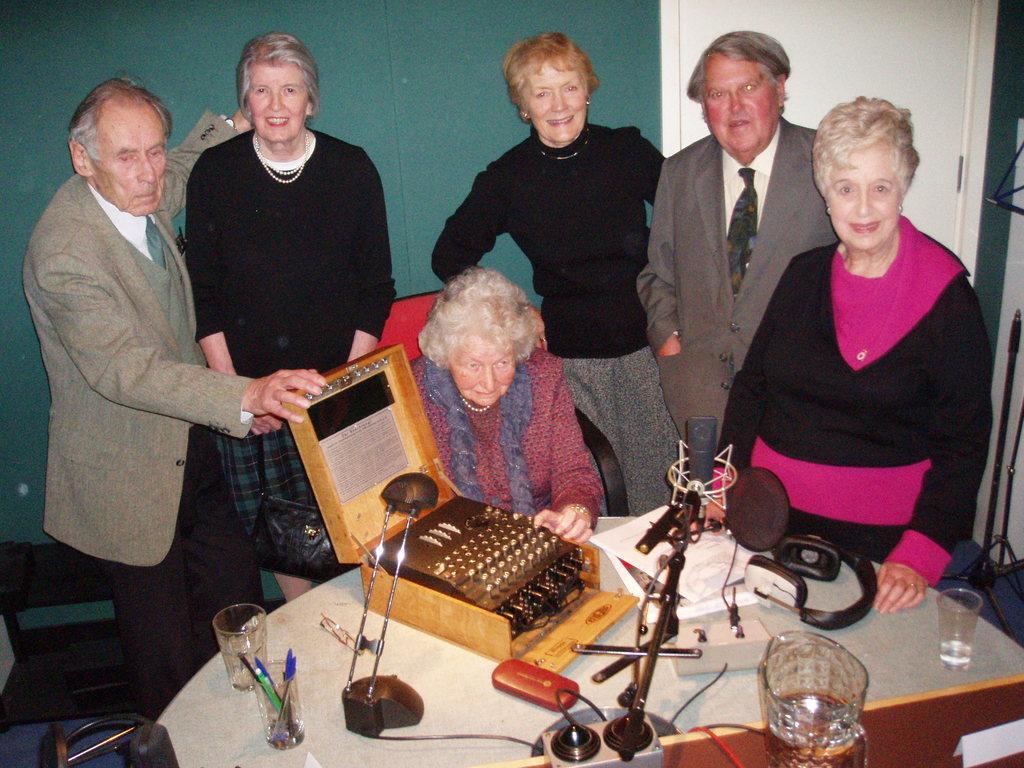Please provide a concise description of this image. At the bottom of the image there is a table with glasses, jar, papers, headset, mic, typewriter and also there are few other items on it. Behind the table there is a lady sitting and few people are standing. Behind them there is a green wall with white door. 